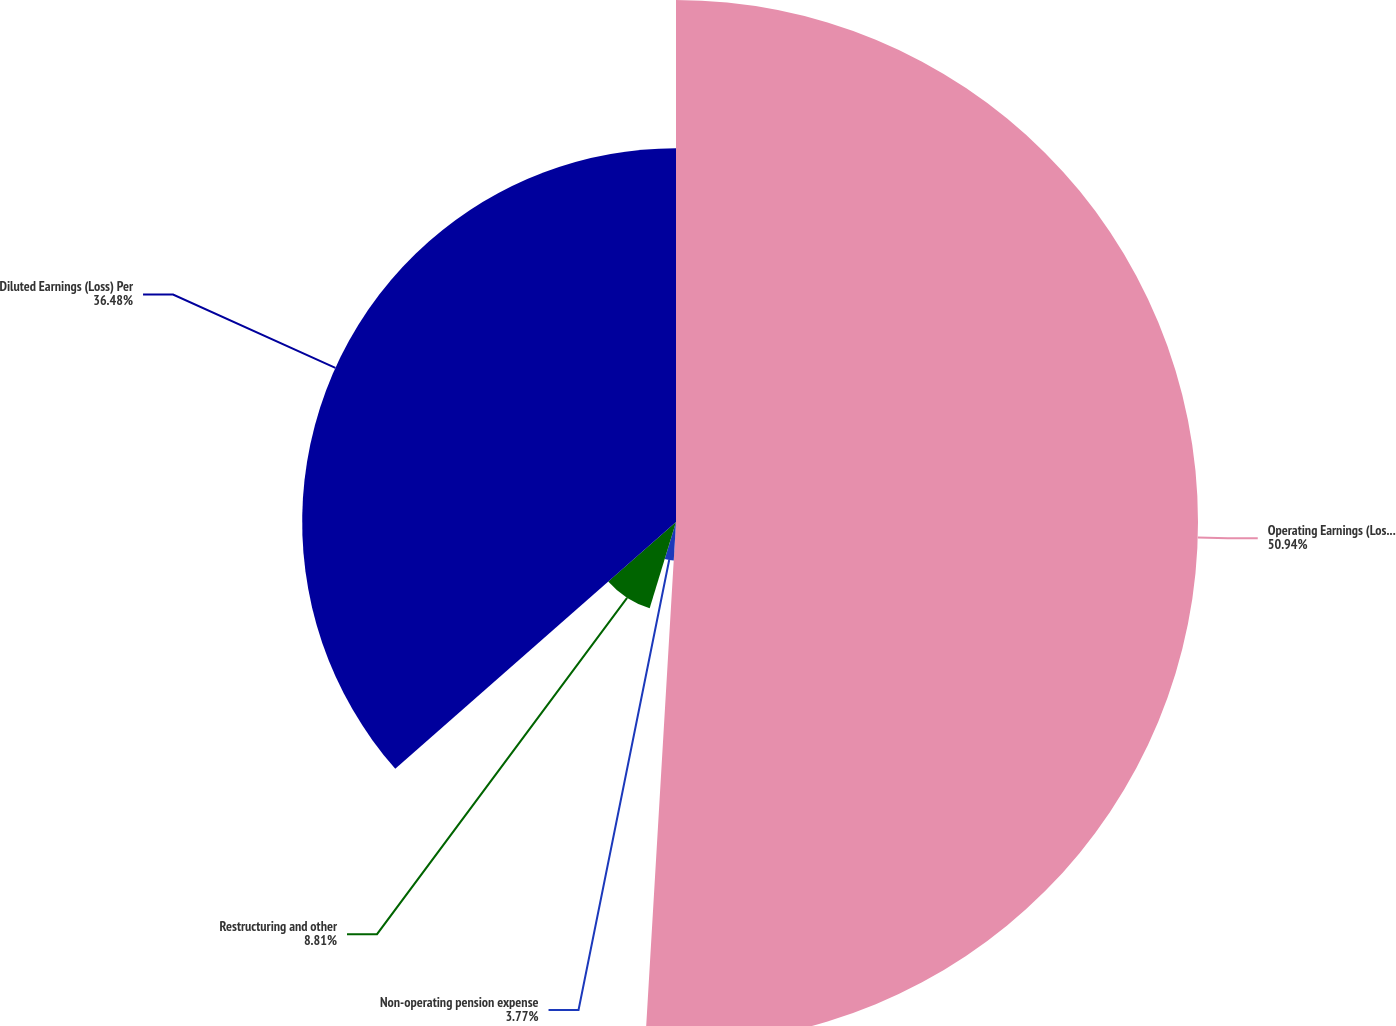Convert chart to OTSL. <chart><loc_0><loc_0><loc_500><loc_500><pie_chart><fcel>Operating Earnings (Loss) Per<fcel>Non-operating pension expense<fcel>Restructuring and other<fcel>Diluted Earnings (Loss) Per<nl><fcel>50.94%<fcel>3.77%<fcel>8.81%<fcel>36.48%<nl></chart> 